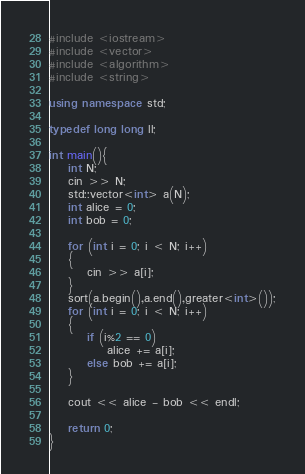Convert code to text. <code><loc_0><loc_0><loc_500><loc_500><_C++_>#include <iostream>
#include <vector>
#include <algorithm>
#include <string>

using namespace std;

typedef long long ll;

int main(){
	int N;
	cin >> N;
	std::vector<int> a(N);
	int alice = 0;
	int bob = 0;

	for (int i = 0; i < N; i++)
	{
		cin >> a[i];
	}
	sort(a.begin(),a.end(),greater<int>());
	for (int i = 0; i < N; i++)
	{
		if (i%2 == 0)
			alice += a[i];
		else bob += a[i];
	}

	cout << alice - bob << endl;

	return 0;
}</code> 